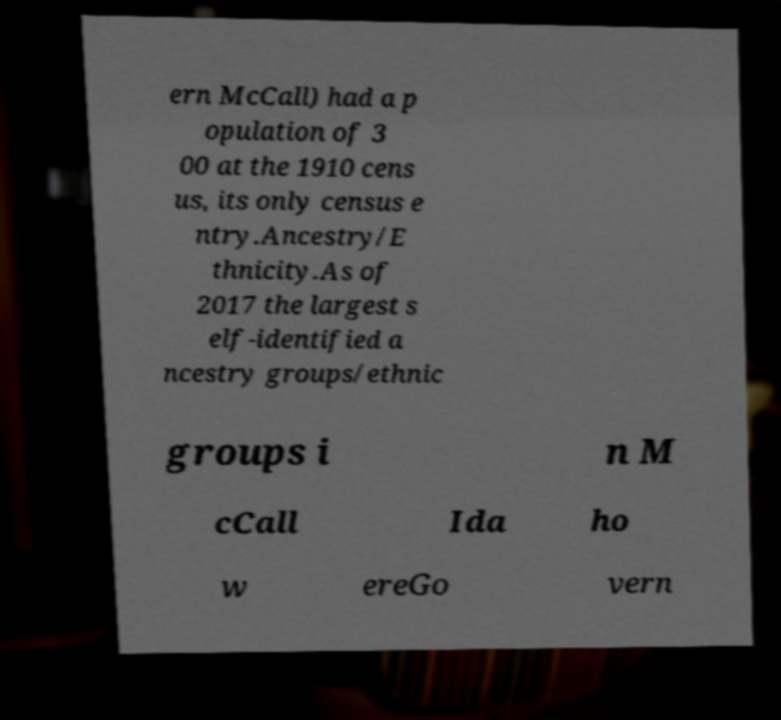Could you assist in decoding the text presented in this image and type it out clearly? ern McCall) had a p opulation of 3 00 at the 1910 cens us, its only census e ntry.Ancestry/E thnicity.As of 2017 the largest s elf-identified a ncestry groups/ethnic groups i n M cCall Ida ho w ereGo vern 